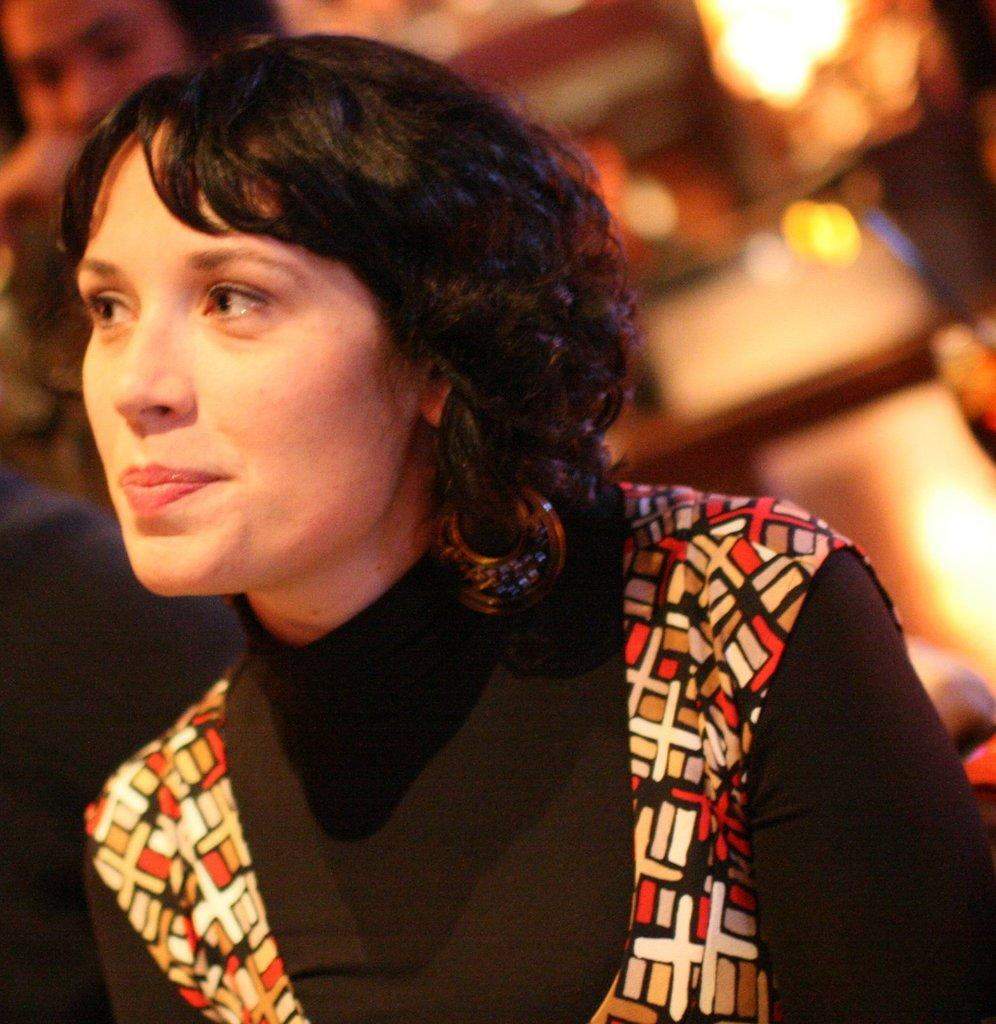Who is present in the image? There is a woman in the image. What is the woman wearing on her upper body? The woman is wearing a black color T-shirt and a waistcoat. What type of accessory is the woman wearing? The woman is wearing earrings. Can you describe the people on the left side of the image? There are two persons on the left side of the image. How would you describe the background of the image? The background of the image is blurry. What type of mask is the woman wearing in the image? There is no mask visible on the woman in the image. Can you tell me how many cherries are on the woman's earrings? The woman is wearing earrings, but there are no cherries present on them. 